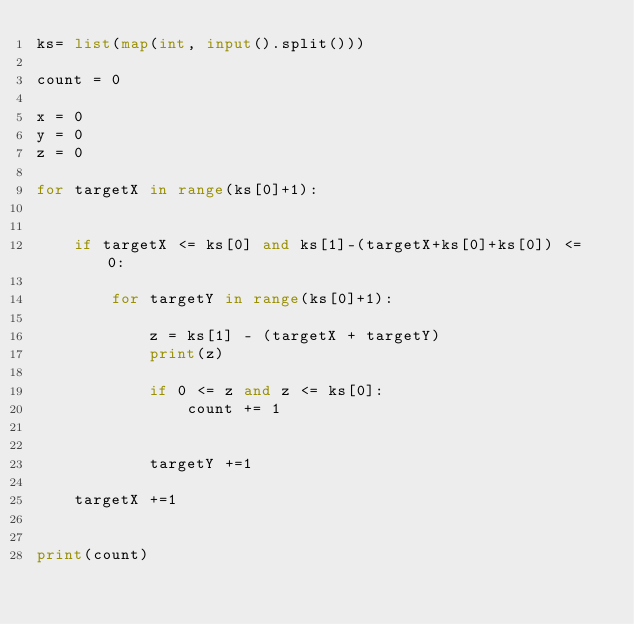<code> <loc_0><loc_0><loc_500><loc_500><_Python_>ks= list(map(int, input().split())) 
 
count = 0
 
x = 0
y = 0
z = 0
 
for targetX in range(ks[0]+1):
    
    
    if targetX <= ks[0] and ks[1]-(targetX+ks[0]+ks[0]) <= 0:
    
        for targetY in range(ks[0]+1):
            
            z = ks[1] - (targetX + targetY)
            print(z)
            
            if 0 <= z and z <= ks[0]:
                count += 1
                
        
            targetY +=1
        
    targetX +=1
        
 
print(count)</code> 